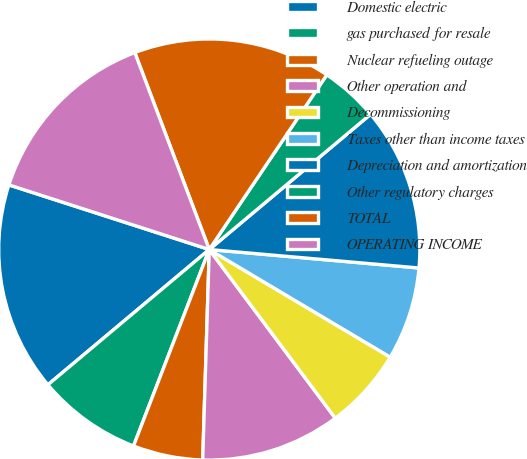Convert chart. <chart><loc_0><loc_0><loc_500><loc_500><pie_chart><fcel>Domestic electric<fcel>gas purchased for resale<fcel>Nuclear refueling outage<fcel>Other operation and<fcel>Decommissioning<fcel>Taxes other than income taxes<fcel>Depreciation and amortization<fcel>Other regulatory charges<fcel>TOTAL<fcel>OPERATING INCOME<nl><fcel>16.07%<fcel>8.04%<fcel>5.36%<fcel>10.71%<fcel>6.25%<fcel>7.14%<fcel>12.5%<fcel>4.47%<fcel>15.18%<fcel>14.28%<nl></chart> 